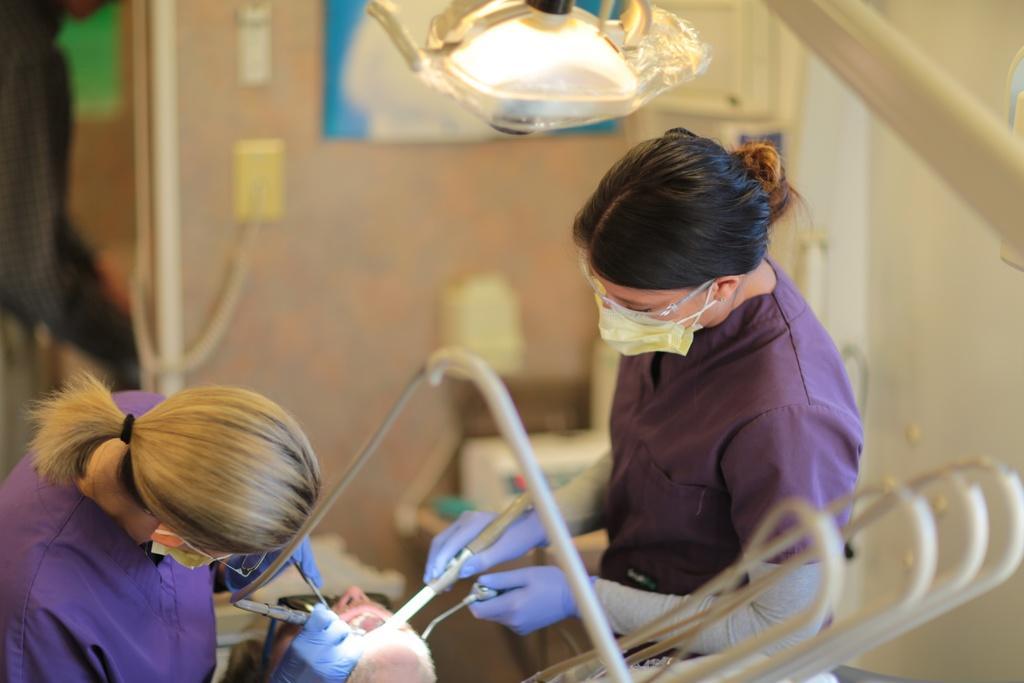How would you summarize this image in a sentence or two? On the left side, there is a woman in violet color dress, holding some objects and giving treatment to the person. On the right side, there is another woman who is in violet color dress, holding objects with both hands and giving treatment to the person and there are pipes. Above them, there is a light attached to the stand. And the background is blurred. 